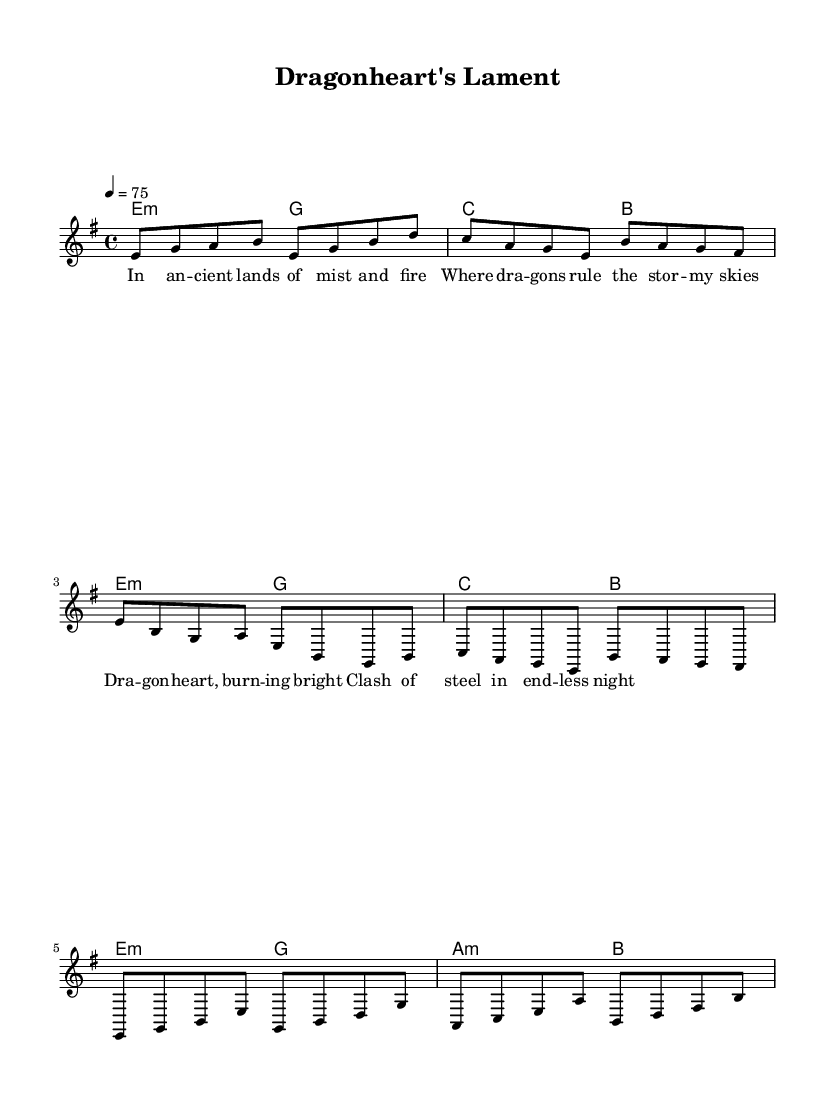What is the key signature of this music? The key signature is e minor, which is indicated by one sharp (F#) shown at the beginning of the staff.
Answer: e minor What is the time signature of the piece? The time signature is 4/4, meaning there are four beats in each measure, as shown in the beginning of the sheet music.
Answer: 4/4 What is the tempo marking for the piece? The tempo marking indicates a speed of 75 beats per minute, specified at the start of the score.
Answer: 75 How many measures are in the chorus section? The chorus is composed of two measures, which can be counted from the notation.
Answer: 2 What are the primary instruments indicated in the score? The score indicates a lead voice and chord names, which suggests vocals with harmonic accompaniment.
Answer: Lead voice and chords What theme is represented in the lyrics? The lyrics focus on dragons and epic battles in a mythical setting, which align with classic power metal themes of fantasy and heroism.
Answer: Mythical creatures and epic battles Which section contains the lyrics "Dragonheart, burning bright"? This line appears in the chorus section, which features lyrics about the dragon's strength and the ongoing battle.
Answer: Chorus 